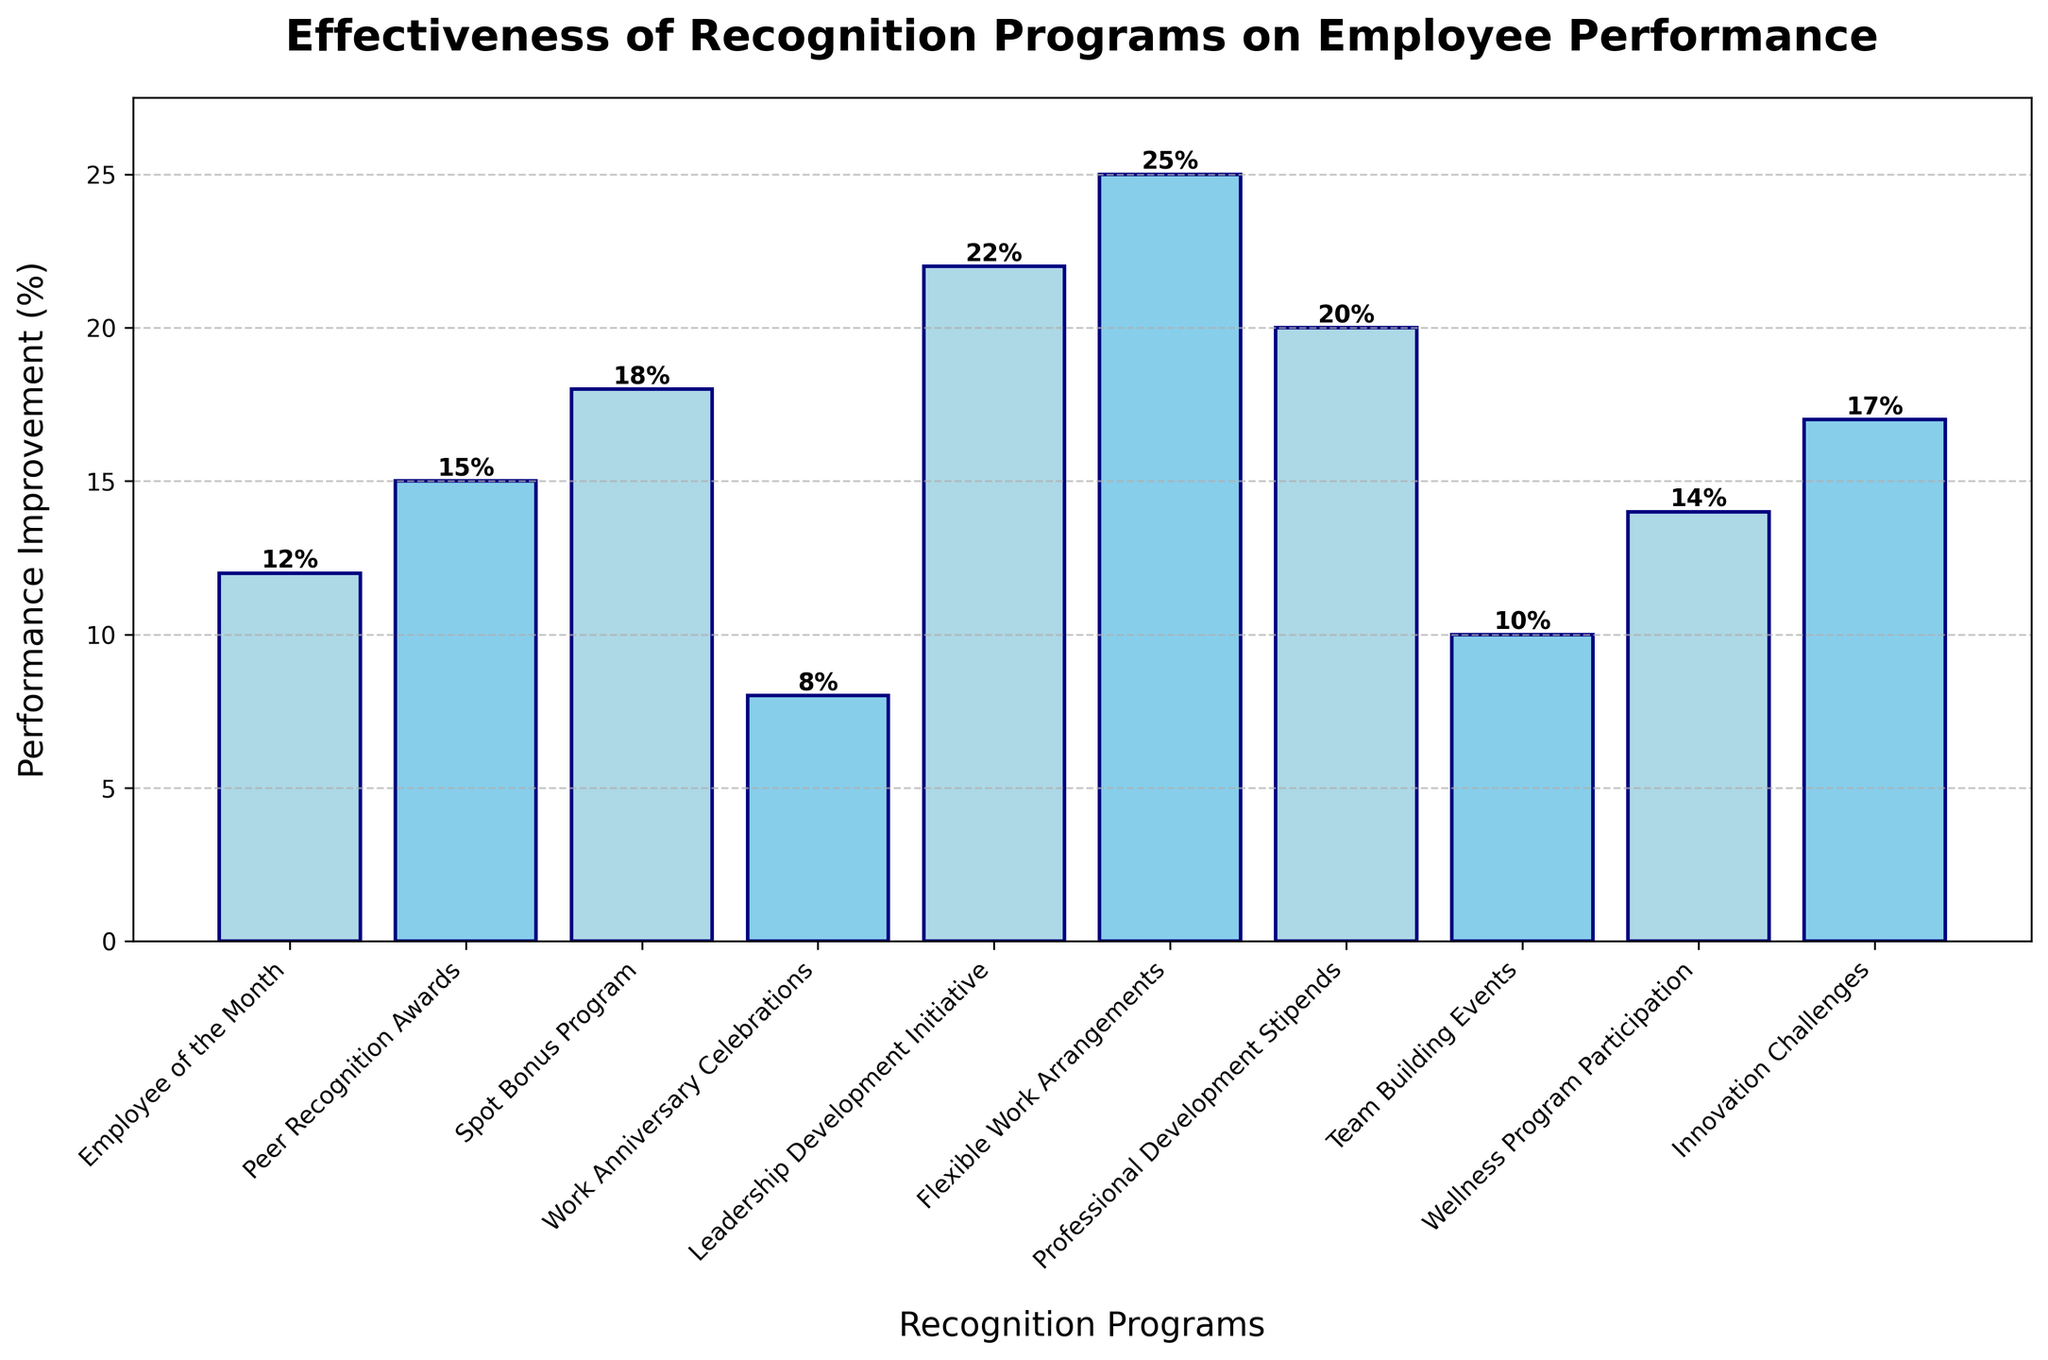Which recognition program has the highest performance improvement? The bar representing "Flexible Work Arrangements" is the tallest among all the bars, indicating that it has the highest performance improvement percentage.
Answer: Flexible Work Arrangements How much higher is the performance improvement for "Leadership Development Initiative" compared to "Team Building Events"? The performance improvement for "Leadership Development Initiative" is 22%, and for "Team Building Events" it is 10%. Subtracting these values gives 22% - 10% = 12%.
Answer: 12% What's the total performance improvement if all programs are combined? Sum of all performance improvements: 12% + 15% + 18% + 8% + 22% + 25% + 20% + 10% + 14% + 17% = 161%.
Answer: 161% Which program is the least effective in improving performance? The bar representing "Work Anniversary Celebrations" is the shortest, indicating it has the lowest performance improvement percentage at 8%.
Answer: Work Anniversary Celebrations What is the average performance improvement across all programs? Sum of all performance improvements is 161%. There are 10 programs, so the average is 161% / 10 = 16.1%.
Answer: 16.1% By how much does the "Spot Bonus Program" exceed the "Employee of the Month" in performance improvement? The performance improvement for "Spot Bonus Program" is 18% and for "Employee of the Month" it is 12%. Subtracting these values gives 18% - 12% = 6%.
Answer: 6% Are there more programs with performance improvements above or below 15%? Programs with improvements above 15% are "Peer Recognition Awards" (15%), "Spot Bonus Program" (18%), "Leadership Development Initiative" (22%), "Flexible Work Arrangements" (25%), "Professional Development Stipends" (20%), and "Innovation Challenges" (17%). Programs below 15% are "Employee of the Month" (12%), "Work Anniversary Celebrations" (8%), "Team Building Events" (10%), and "Wellness Program Participation" (14%). Thus, there are 6 programs above and 4 programs below 15%.
Answer: Above Which programs have performance improvement percentages that are at least 20%? The programs are "Leadership Development Initiative" (22%), "Flexible Work Arrangements" (25%), and "Professional Development Stipends" (20%).
Answer: Leadership Development Initiative, Flexible Work Arrangements, Professional Development Stipends What's the median performance improvement? Ordering the improvements: 8%, 10%, 12%, 14%, 15%, 17%, 18%, 20%, 22%, 25%. The median is the average of the 5th and 6th values: (15% + 17%) / 2 = 16%.
Answer: 16% What is the difference between the highest and lowest performance improvements? The highest performance improvement is "Flexible Work Arrangements" at 25% and the lowest is "Work Anniversary Celebrations" at 8%. Subtracting these values gives 25% - 8% = 17%.
Answer: 17% 